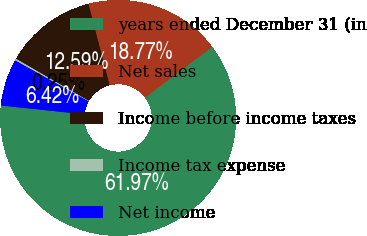Convert chart. <chart><loc_0><loc_0><loc_500><loc_500><pie_chart><fcel>years ended December 31 (in<fcel>Net sales<fcel>Income before income taxes<fcel>Income tax expense<fcel>Net income<nl><fcel>61.98%<fcel>18.77%<fcel>12.59%<fcel>0.25%<fcel>6.42%<nl></chart> 